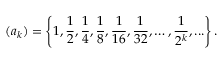<formula> <loc_0><loc_0><loc_500><loc_500>( a _ { k } ) = \left \{ 1 , { \frac { 1 } { 2 } } , { \frac { 1 } { 4 } } , { \frac { 1 } { 8 } } , { \frac { 1 } { 1 6 } } , { \frac { 1 } { 3 2 } } , \dots , { \frac { 1 } { 2 ^ { k } } } , \dots \right \} .</formula> 